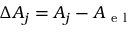<formula> <loc_0><loc_0><loc_500><loc_500>\Delta A _ { j } = A _ { j } - A _ { e l }</formula> 